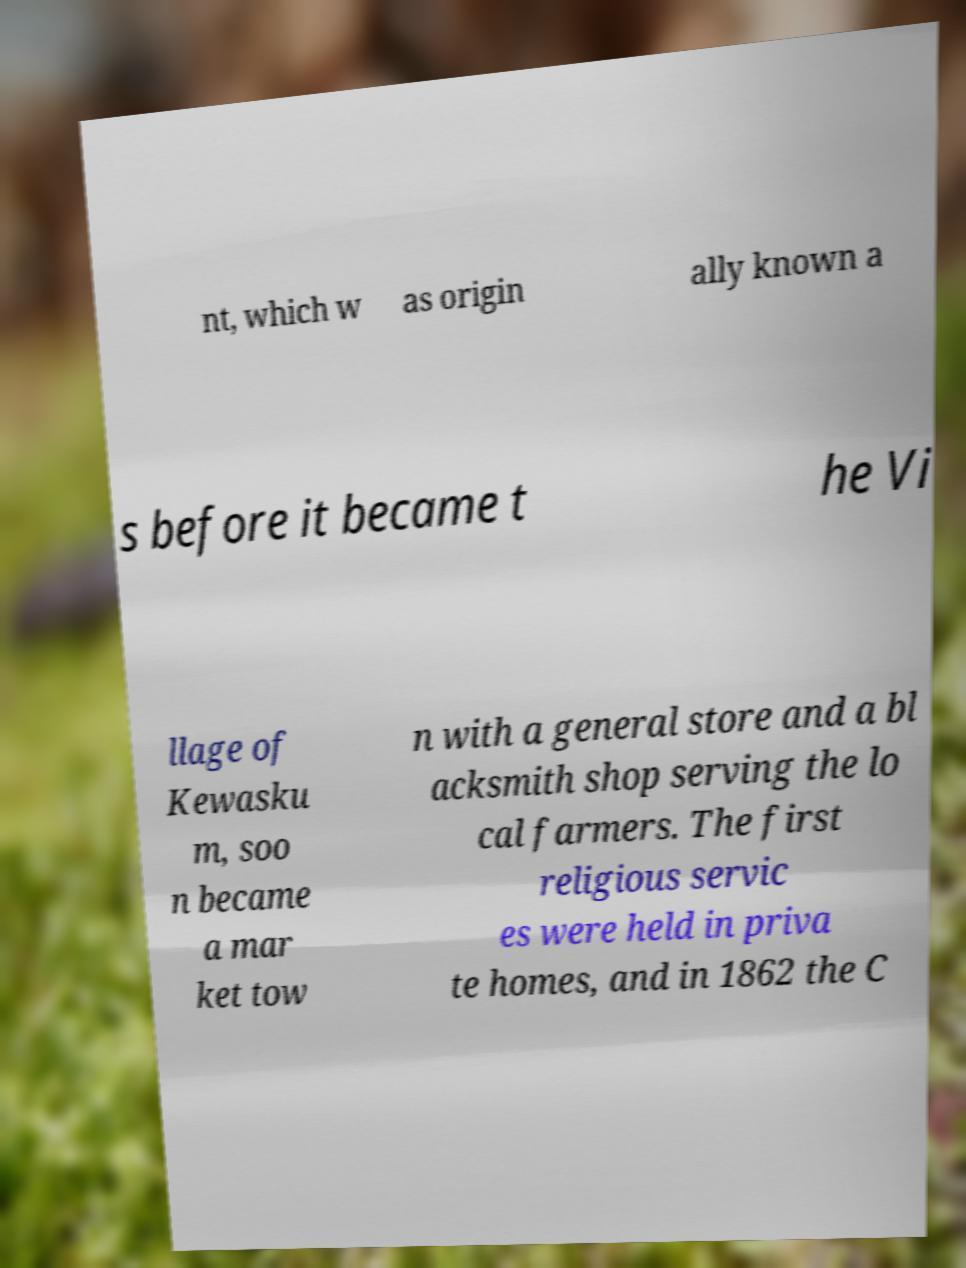I need the written content from this picture converted into text. Can you do that? nt, which w as origin ally known a s before it became t he Vi llage of Kewasku m, soo n became a mar ket tow n with a general store and a bl acksmith shop serving the lo cal farmers. The first religious servic es were held in priva te homes, and in 1862 the C 